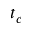<formula> <loc_0><loc_0><loc_500><loc_500>t _ { c }</formula> 